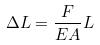<formula> <loc_0><loc_0><loc_500><loc_500>\Delta L = \frac { F } { E A } L</formula> 